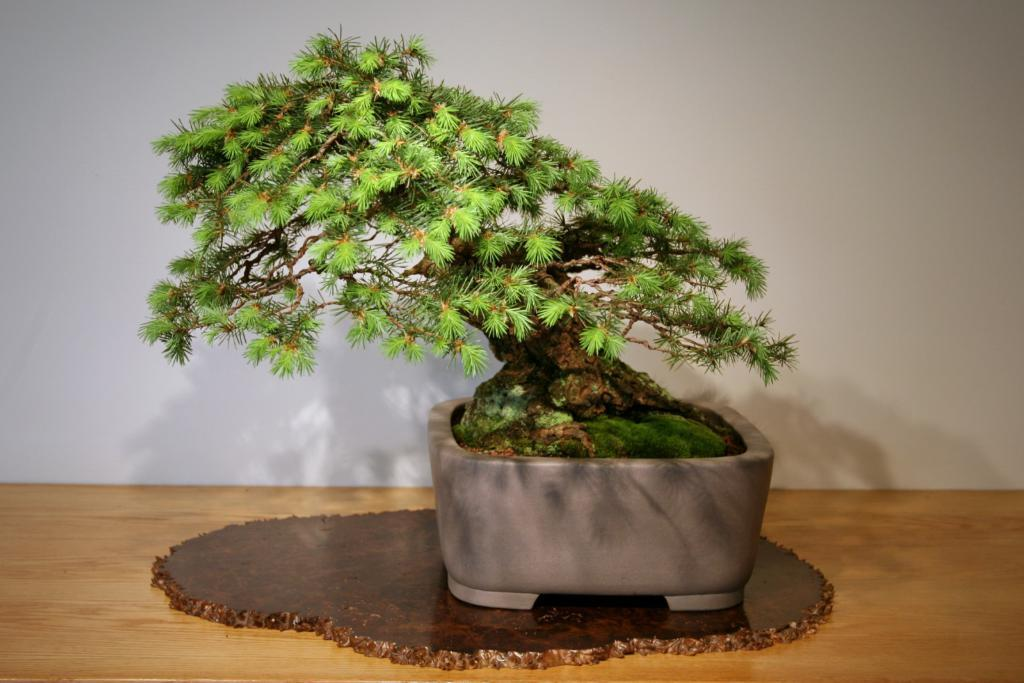What type of plant is in the picture? There is a bonsai tree in the picture. What is the bonsai tree placed on? The bonsai tree is on a brown surface. What can be seen in the background of the picture? There is a white color wall in the background of the picture. Is the bonsai tree's brother visible in the picture? There is no mention of a brother for the bonsai tree, and plants do not have siblings. 